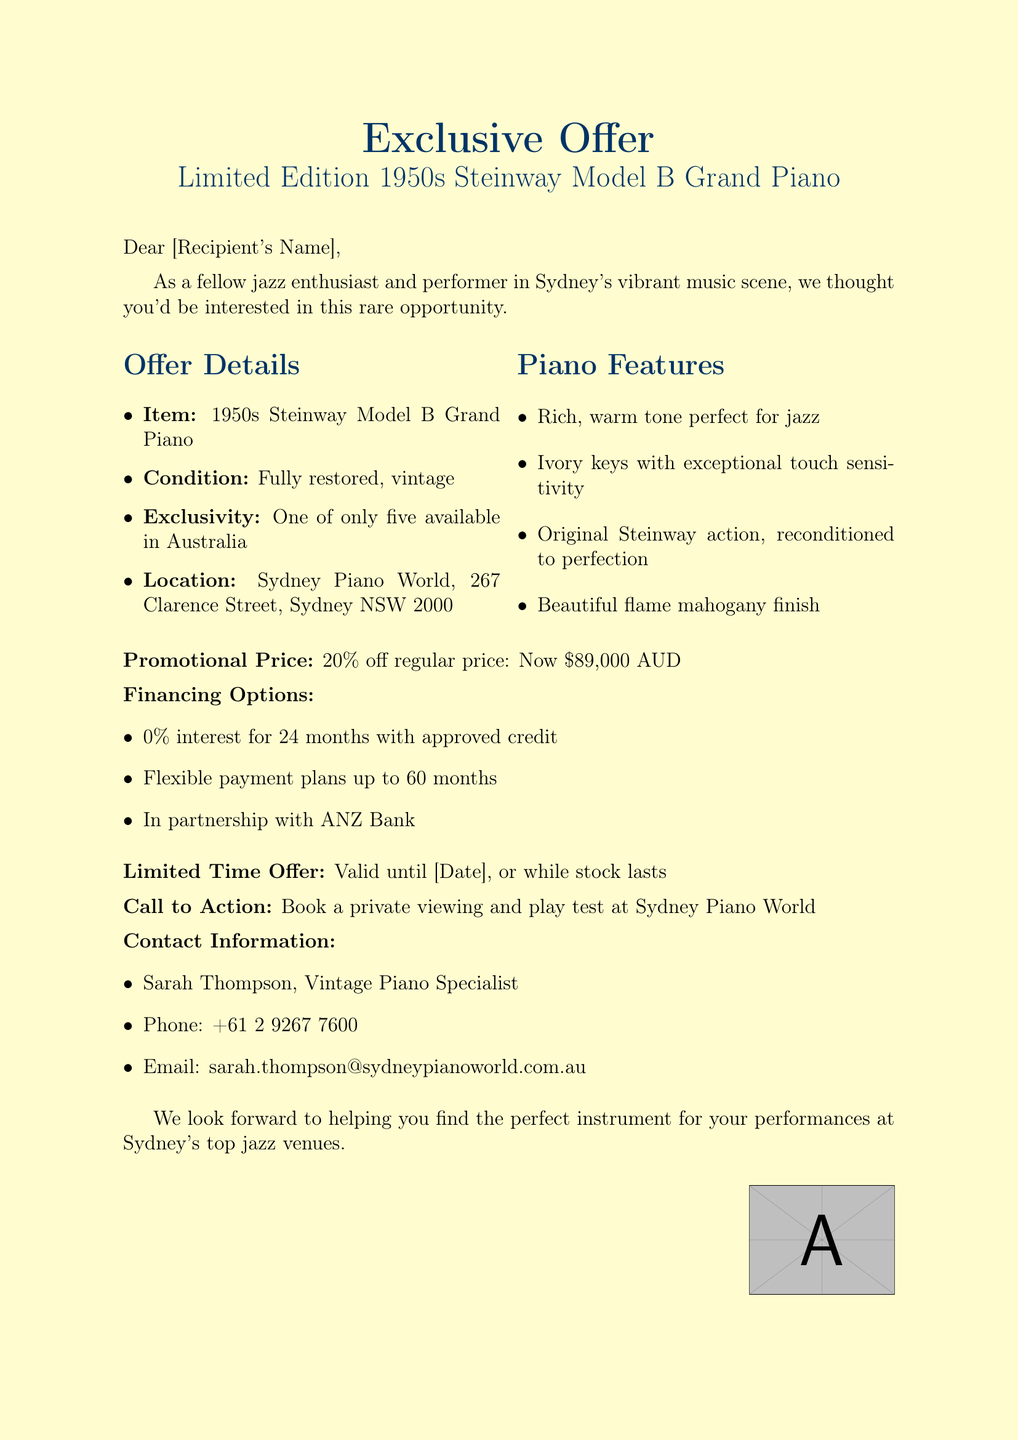What is the subject of the email? The subject of the email is presented at the beginning and is "Exclusive Offer: Limited Edition 1950s Steinway Model B Grand Piano."
Answer: Exclusive Offer: Limited Edition 1950s Steinway Model B Grand Piano Who is the contact person for this offer? The contact person mentioned in the email for inquiries is Sarah Thompson.
Answer: Sarah Thompson What is the promotional price of the piano? The promotional price listed in the document is discounted by 20%, making it $89,000 AUD.
Answer: $89,000 AUD How many of these pianos are available in Australia? The document states that there are only five of these pianos available in Australia.
Answer: Five What are the financing options available? The document lists two financing options: 0% interest for 24 months and flexible payment plans up to 60 months.
Answer: 0% interest for 24 months, flexible payment plans up to 60 months What feature of the piano is highlighted for its suitability for jazz? The rich, warm tone is highlighted as a feature perfect for jazz.
Answer: Rich, warm tone Where is the piano located? The document mentions that the piano is located at Sydney Piano World, specifically at 267 Clarence Street, Sydney NSW 2000.
Answer: Sydney Piano World, 267 Clarence Street, Sydney NSW 2000 Until when is the offer valid? The email indicates that the offer is valid until a specified date or while stock lasts.
Answer: Until [Date], or while stock lasts What is the primary call to action in the email? The primary call to action encourages recipients to book a private viewing and play test at the store.
Answer: Book a private viewing and play test at Sydney Piano World 